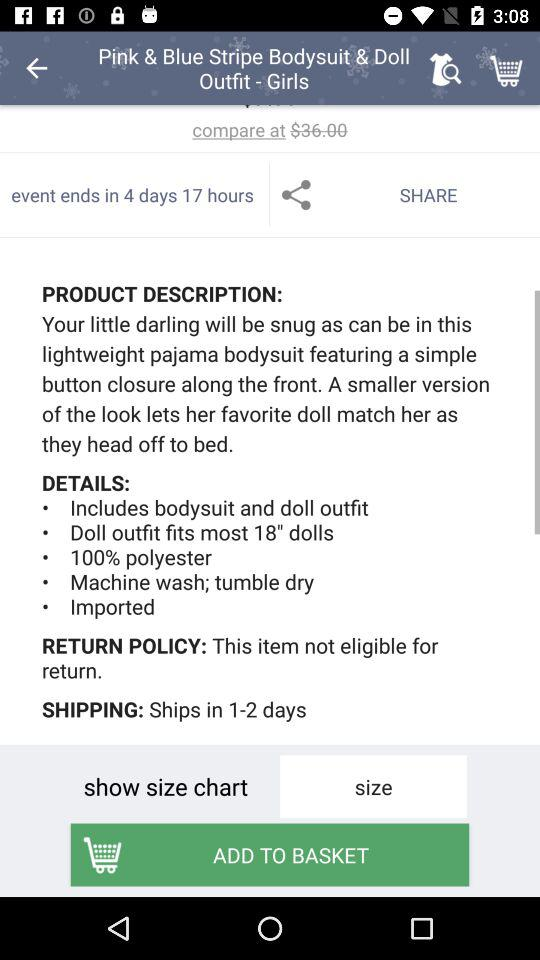How many days does shipping take?
Answer the question using a single word or phrase. 1-2 days 